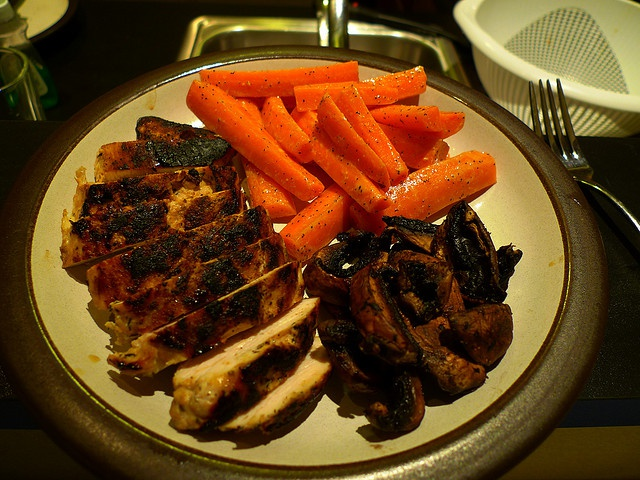Describe the objects in this image and their specific colors. I can see carrot in olive, maroon, and red tones, carrot in olive, red, brown, and maroon tones, carrot in olive, red, and brown tones, carrot in olive, red, brown, and orange tones, and carrot in olive, red, and orange tones in this image. 